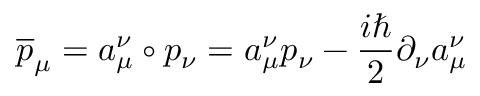Convert formula to latex. <formula><loc_0><loc_0><loc_500><loc_500>\overline { p } _ { \mu } = a _ { \mu } ^ { \nu } \circ p _ { \nu } = a _ { \mu } ^ { \nu } p _ { \nu } - \frac { i } { 2 } \partial _ { \nu } a _ { \mu } ^ { \nu }</formula> 